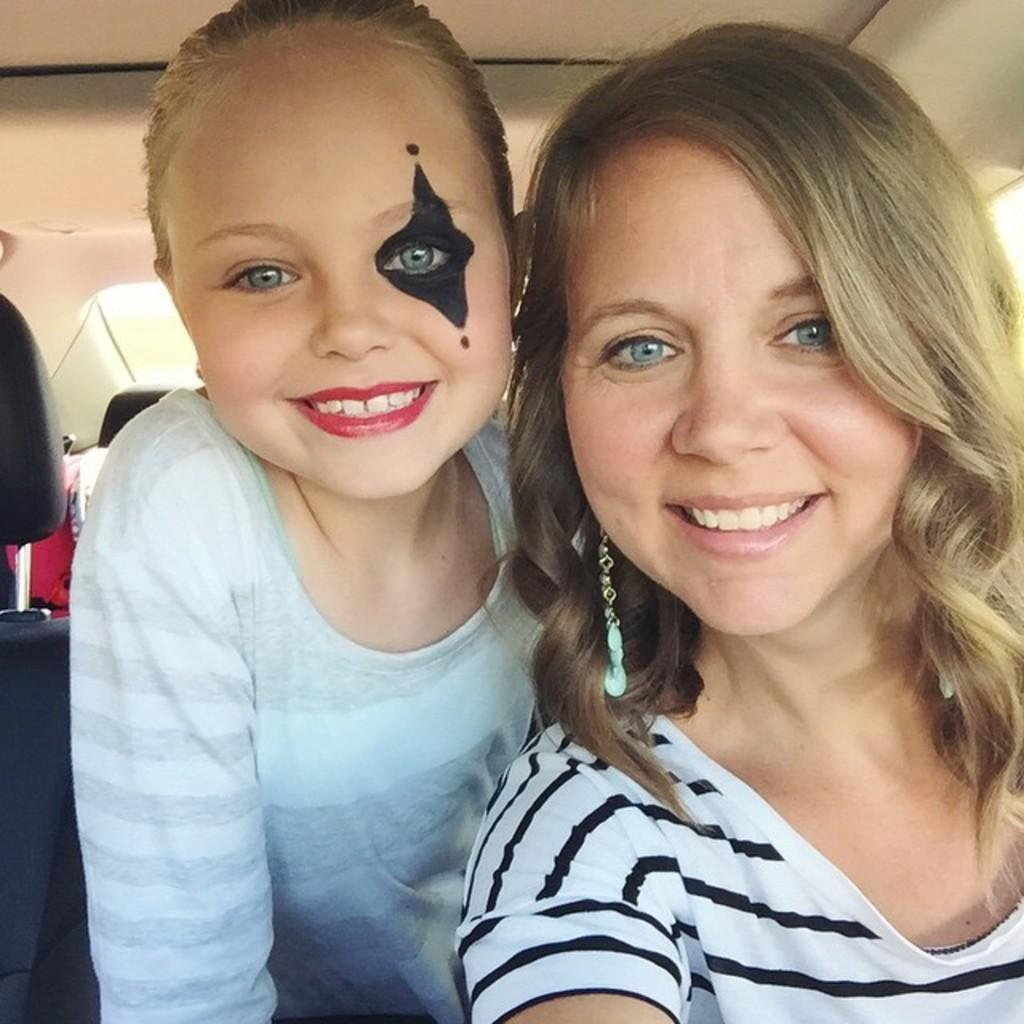What is the setting of the image? The image shows the inside view of a vehicle. Who can be seen in the image? There is a woman and a girl in the image. What is the facial expression of the woman and the girl? Both the woman and the girl are smiling. What type of furniture is present in the vehicle? There are seats in the vehicle. What other items can be seen in the vehicle? There are other objects present in the vehicle. Can you see an airport or a tent in the image? No, there is no airport or tent visible in the image; it shows the inside view of a vehicle. 